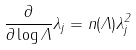<formula> <loc_0><loc_0><loc_500><loc_500>\frac { \partial } { \partial \log \Lambda } \lambda _ { j } = n ( \Lambda ) \lambda _ { j } ^ { 2 }</formula> 